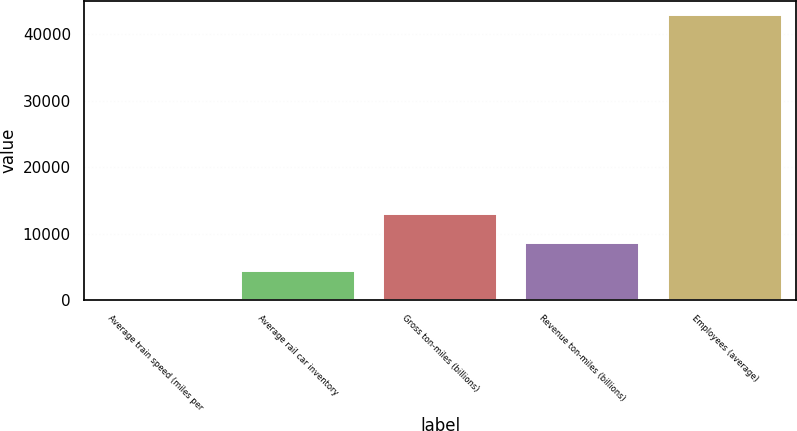<chart> <loc_0><loc_0><loc_500><loc_500><bar_chart><fcel>Average train speed (miles per<fcel>Average rail car inventory<fcel>Gross ton-miles (billions)<fcel>Revenue ton-miles (billions)<fcel>Employees (average)<nl><fcel>26.2<fcel>4311.98<fcel>12883.5<fcel>8597.76<fcel>42884<nl></chart> 